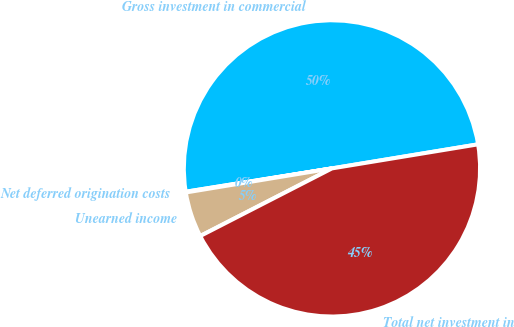<chart> <loc_0><loc_0><loc_500><loc_500><pie_chart><fcel>Gross investment in commercial<fcel>Net deferred origination costs<fcel>Unearned income<fcel>Total net investment in<nl><fcel>49.92%<fcel>0.08%<fcel>4.95%<fcel>45.05%<nl></chart> 